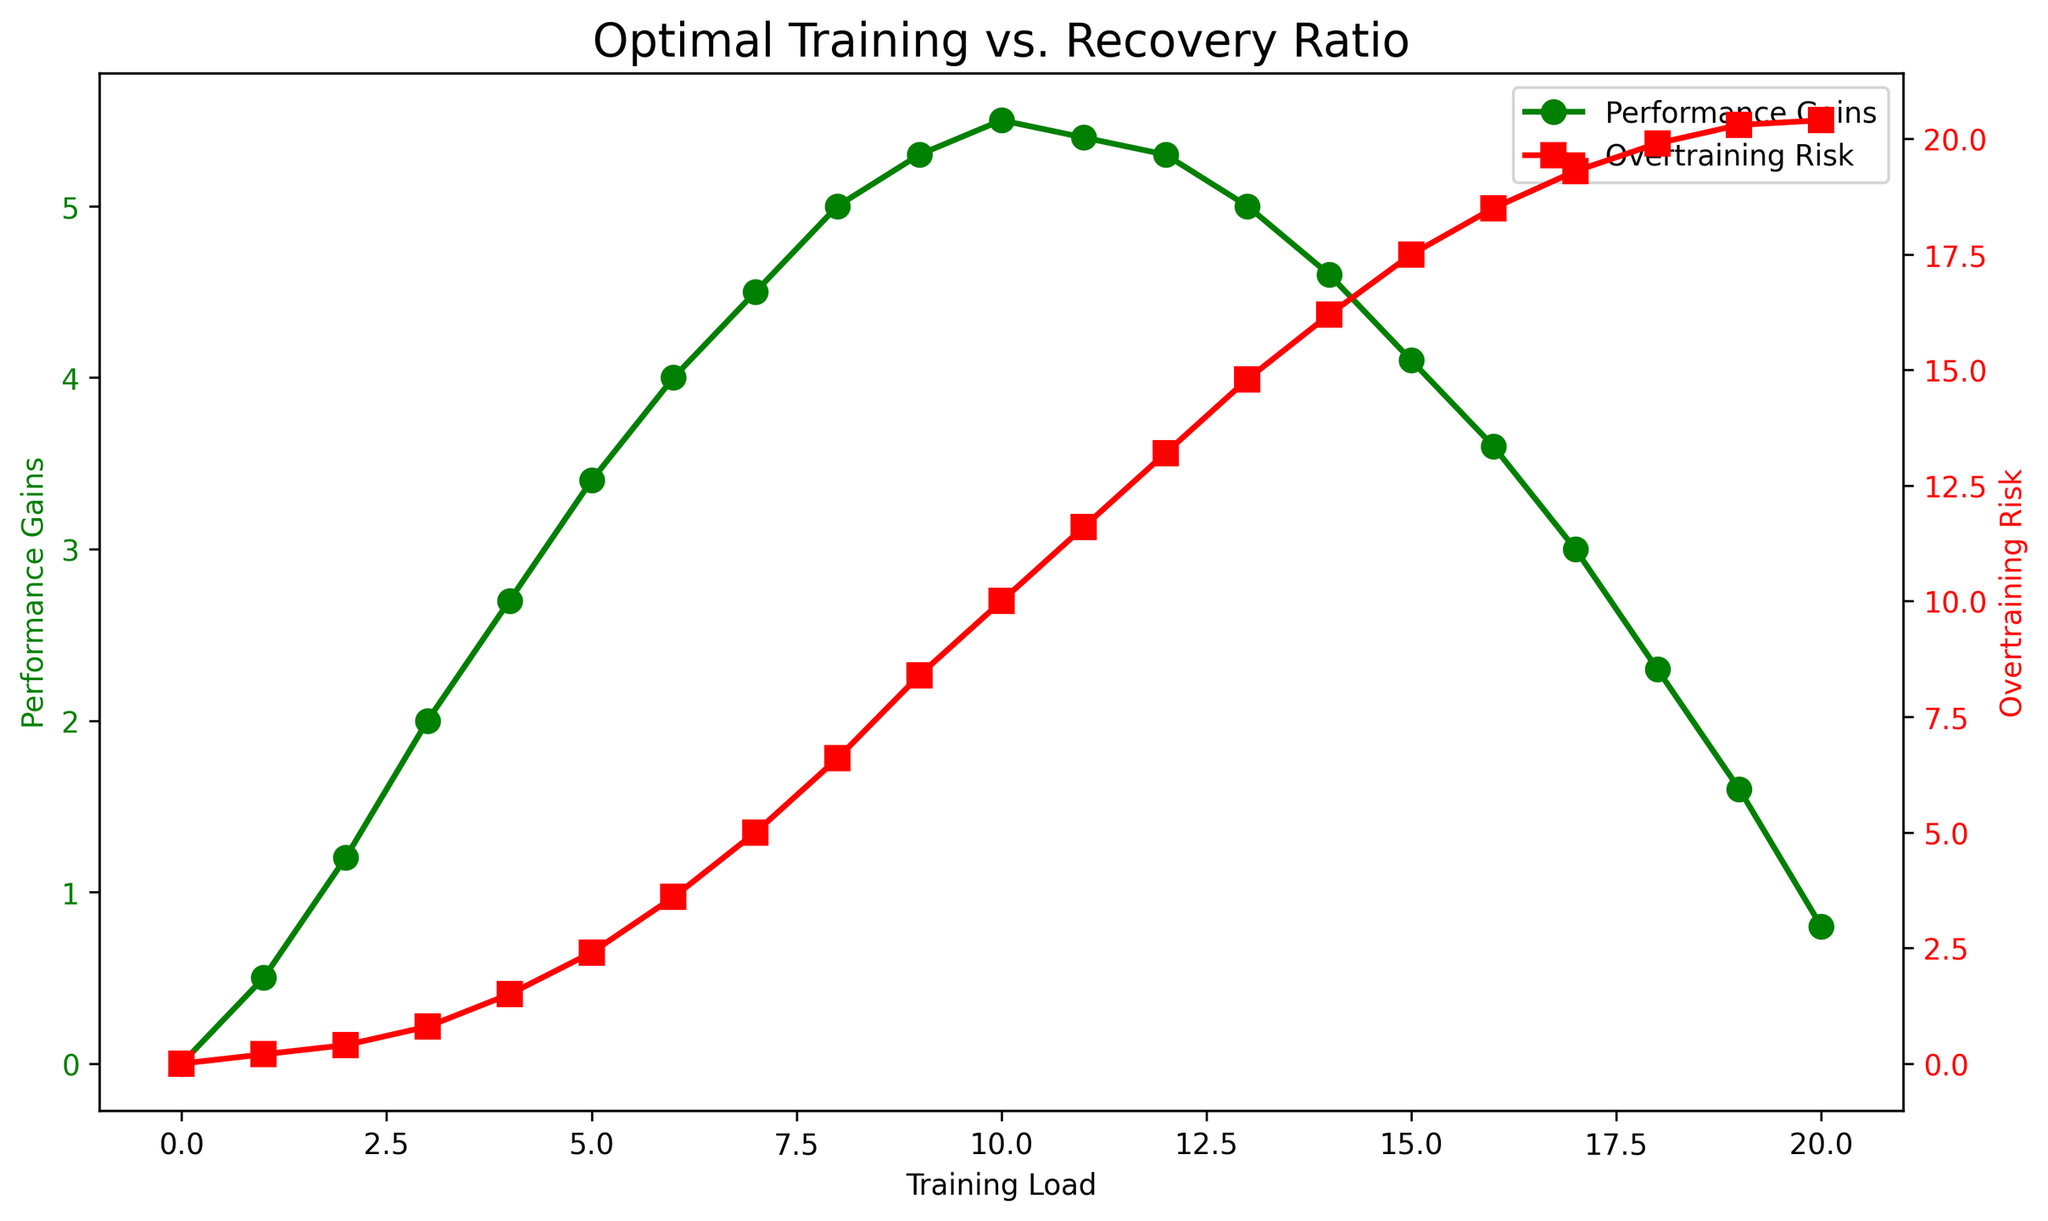What is the highest point of performance gains? The highest point of performance gains can be determined by checking the peak value on the green line representing performance gains. The peak is at a training load of 10 with a performance gain of 5.5.
Answer: 5.5 At what training load does overtraining risk first exceed 10? By following the red line representing overtraining risk, we observe that it first exceeds 10 at a training load of 10.
Answer: 10 What is the difference in performance gains between training loads 5 and 8? Performance gains at training load 5 are 3.4, and at training load 8 are 5.0. The difference is 5.0 - 3.4 = 1.6.
Answer: 1.6 At what training load is the performance gain closest to the overtraining risk value? To find this, compare the values of performance gains and overtraining risk for each training load. The closest values are at training load 10, where performance gain is 5.5 and overtraining risk is 10, giving the smallest difference.
Answer: 10 At which training load does the performance gain start to decline? The decline in performance gain starts right after the peak. Following the green line, we see that performance gain peaks at training load 10 and starts to decline at training load 11.
Answer: 11 What is the average overtraining risk between training loads 0 and 10? The overtraining risk between training loads 0 and 10 are: 0, 0.2, 0.4, 0.8, 1.5, 2.4, 3.6, 5.0, 6.6, 8.4, 10. Sum these values: 0 + 0.2 + 0.4 + 0.8 + 1.5 + 2.4 + 3.6 + 5.0 + 6.6 + 8.4 + 10 = 38.9. Average is 38.9 / 11 = 3.536.
Answer: 3.536 Which training load shows a greater increase in performance gain compared to overtraining risk? To find this, we need to identify where the difference between the increase (rise) of performance gain and overtraining risk is the largest. Comparing each increment from training load 0 to 10, we observe that from 6 to 7, the performance gain increase is the highest (4.0 to 4.5) and the overtraining risk increase is also significant. However, the largest difference is seen from 4 to 5, with performance gain increasing from 3.4 to 4.0 making it a greater increase compared to overtraining risk.
Answer: 5 